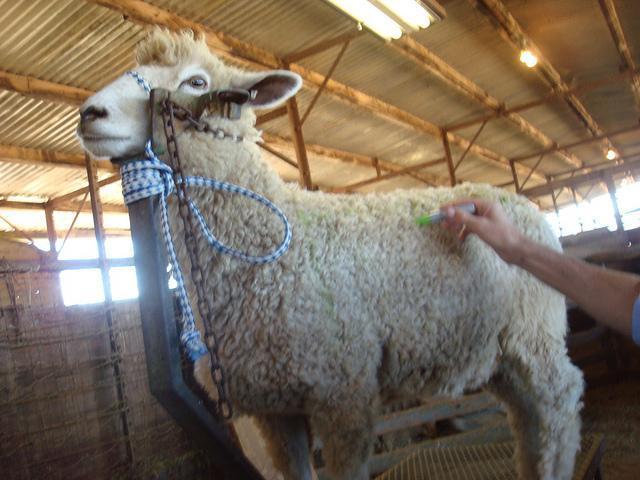How many bikes are there?
Give a very brief answer. 0. 